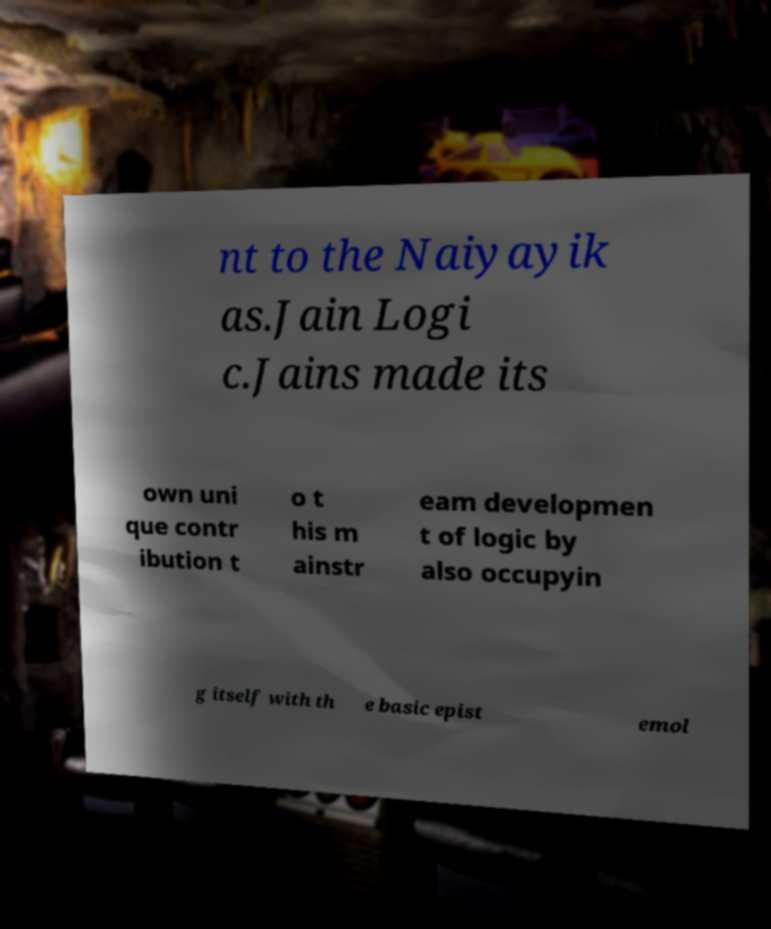Please identify and transcribe the text found in this image. nt to the Naiyayik as.Jain Logi c.Jains made its own uni que contr ibution t o t his m ainstr eam developmen t of logic by also occupyin g itself with th e basic epist emol 